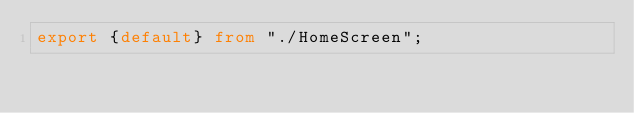<code> <loc_0><loc_0><loc_500><loc_500><_TypeScript_>export {default} from "./HomeScreen";
</code> 